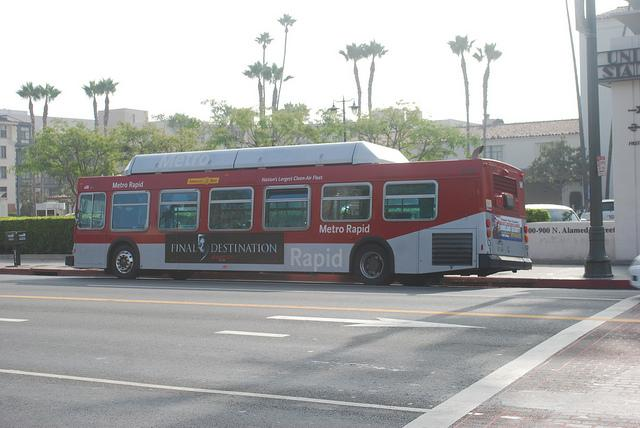What type of vehicle is this? bus 